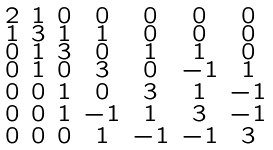<formula> <loc_0><loc_0><loc_500><loc_500>\begin{smallmatrix} 2 & 1 & 0 & 0 & 0 & 0 & 0 \\ 1 & 3 & 1 & 1 & 0 & 0 & 0 \\ 0 & 1 & 3 & 0 & 1 & 1 & 0 \\ 0 & 1 & 0 & 3 & 0 & - 1 & 1 \\ 0 & 0 & 1 & 0 & 3 & 1 & - 1 \\ 0 & 0 & 1 & - 1 & 1 & 3 & - 1 \\ 0 & 0 & 0 & 1 & - 1 & - 1 & 3 \end{smallmatrix}</formula> 